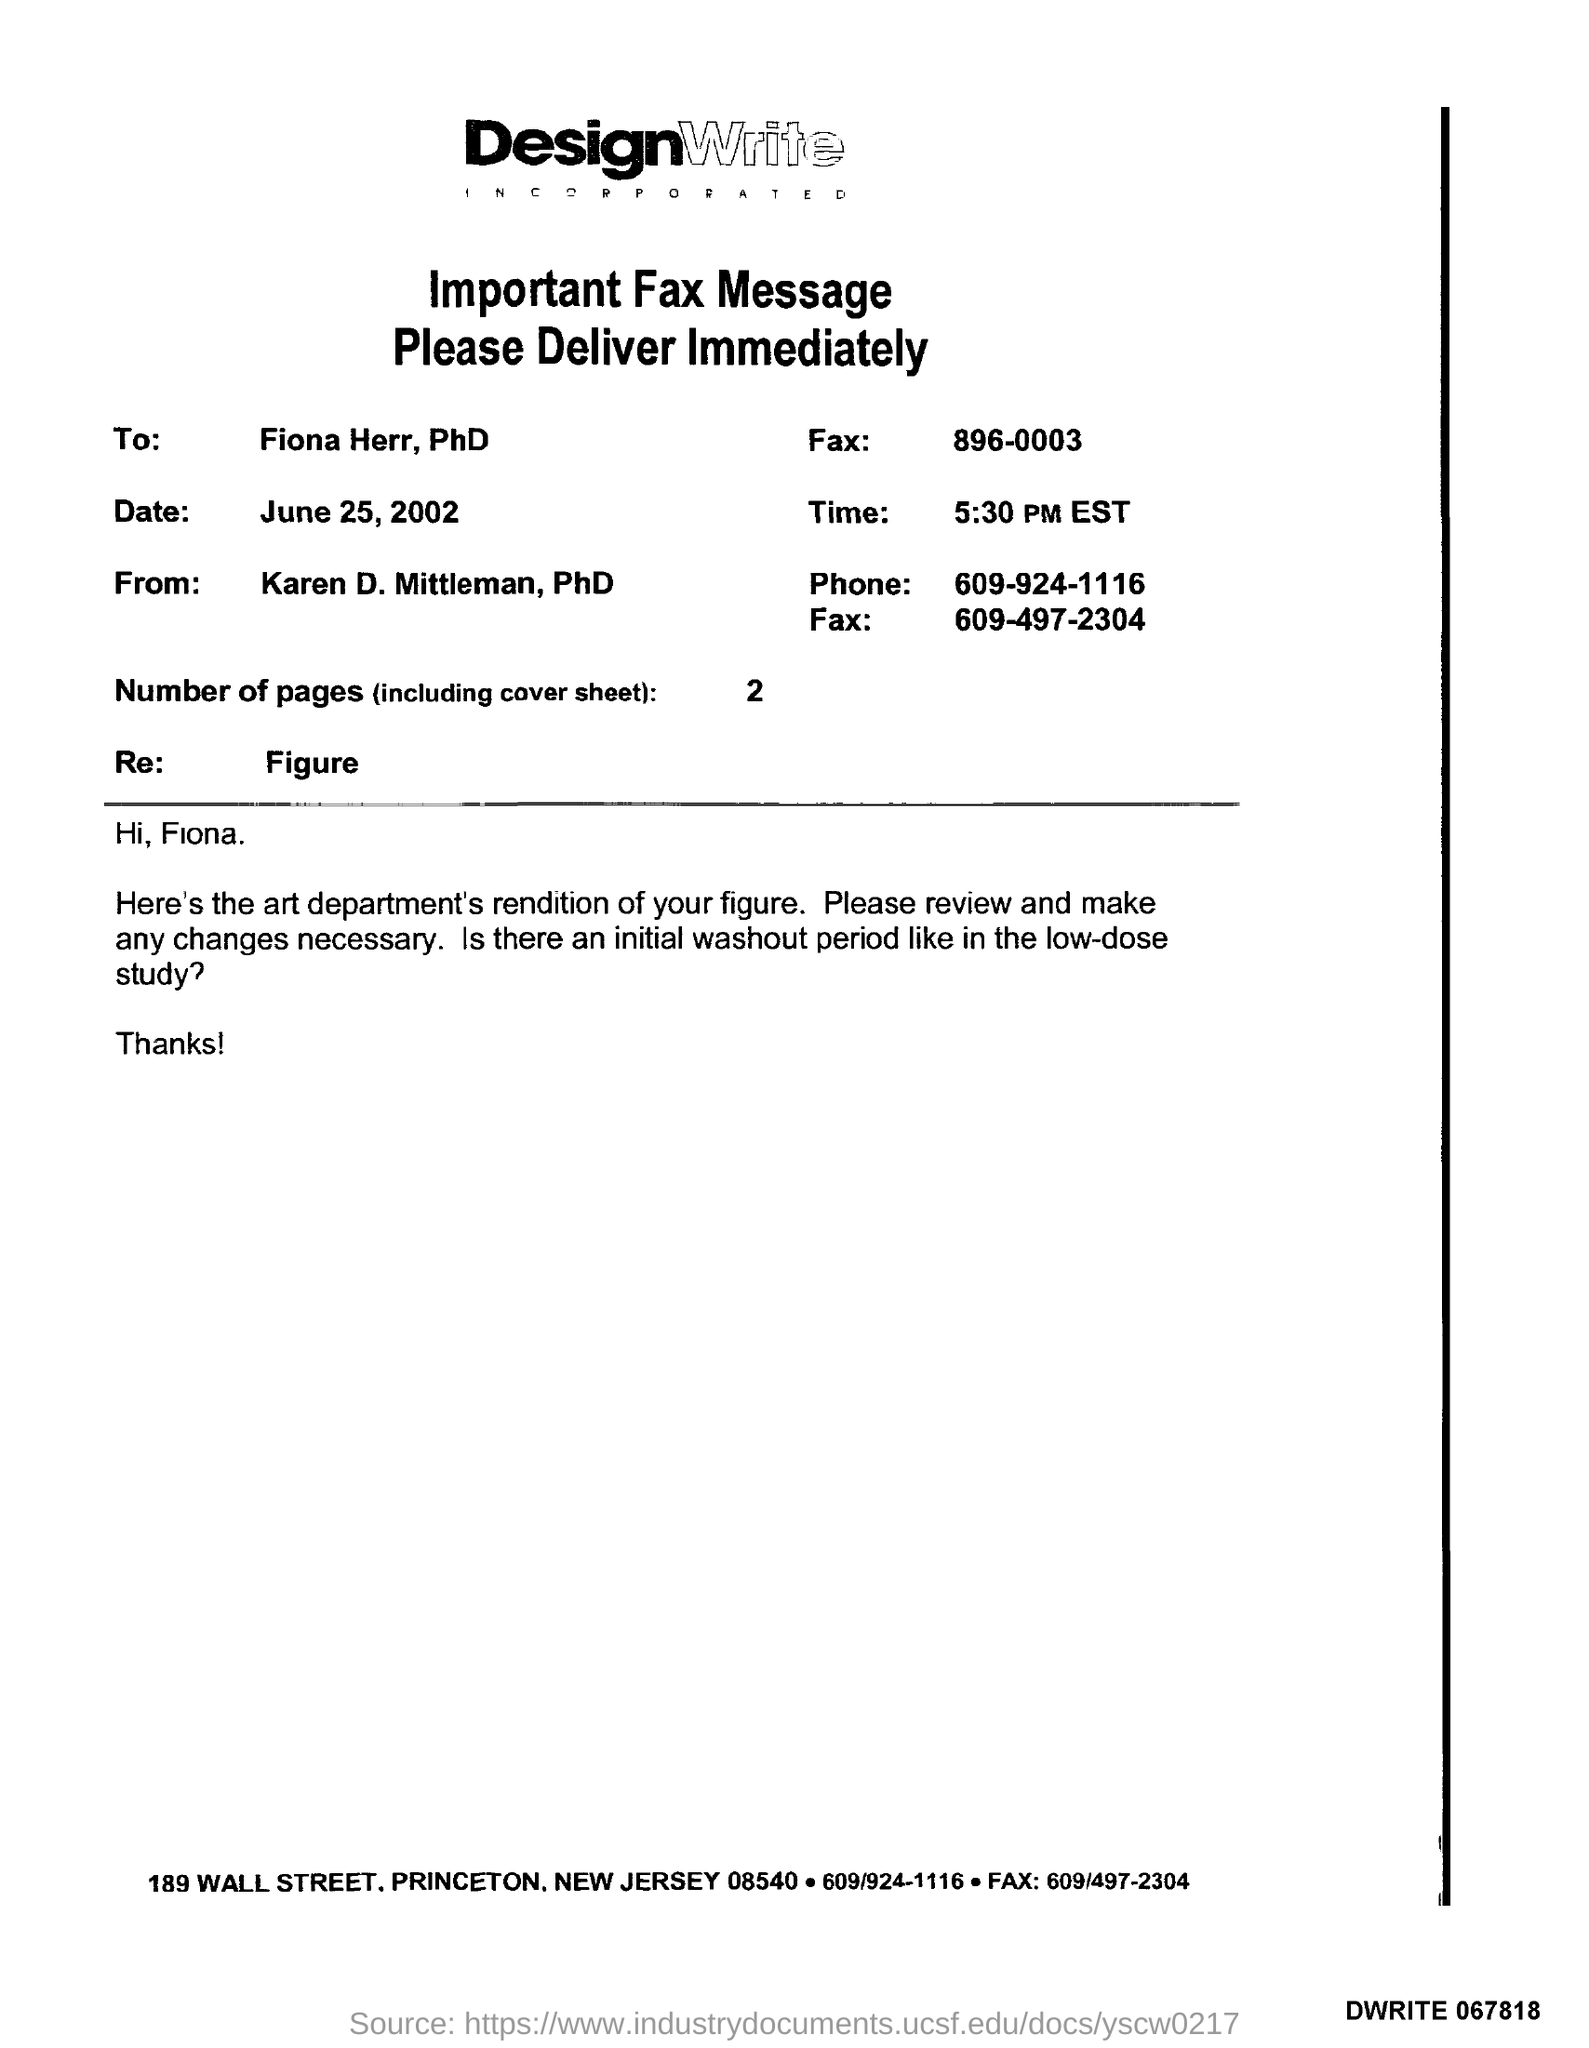To whom is the fax addressed?
Your answer should be compact. Fiona herr. What is Fiona's Fax number?
Your response must be concise. 896-0003. When is the fax dated?
Provide a succinct answer. June 25, 2002. From whom is the fax?
Ensure brevity in your answer.  Karen D. Mittleman, PhD. What is the time given?
Give a very brief answer. 5:30 PM EST. How many pages are there including cover sheet?
Your answer should be very brief. 2. What is Karen's phone number?
Offer a very short reply. 609-924-1116. 